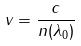<formula> <loc_0><loc_0><loc_500><loc_500>v = \frac { c } { n ( \lambda _ { 0 } ) }</formula> 